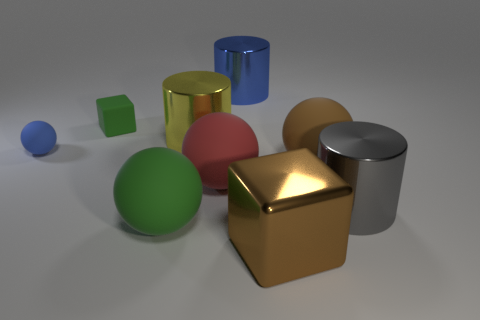What number of objects are blue spheres or big shiny things that are on the left side of the big brown matte sphere? After carefully examining the image, I can see that there are two objects fitting the description: one blue sphere and one big shiny metallic sphere to the left of the large brown matte sphere. 